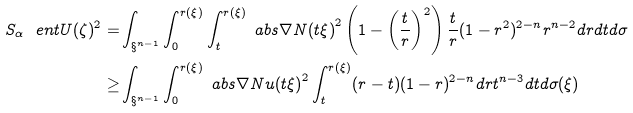<formula> <loc_0><loc_0><loc_500><loc_500>S _ { \alpha } \ e n t { U } ( \zeta ) ^ { 2 } = & \int _ { \S ^ { n - 1 } } \int _ { 0 } ^ { r ( \xi ) } \int _ { t } ^ { r ( \xi ) } \ a b s { \nabla N ( t \xi ) } ^ { 2 } \left ( 1 - \left ( \frac { t } { r } \right ) ^ { 2 } \right ) \frac { t } { r } ( 1 - r ^ { 2 } ) ^ { 2 - n } r ^ { n - 2 } d r d t d \sigma \\ \geq & \int _ { \S ^ { n - 1 } } \int _ { 0 } ^ { r ( \xi ) } \ a b s { \nabla N u ( t \xi ) } ^ { 2 } \int _ { t } ^ { r ( \xi ) } ( r - t ) ( 1 - r ) ^ { 2 - n } d r t ^ { n - 3 } d t d \sigma ( \xi )</formula> 